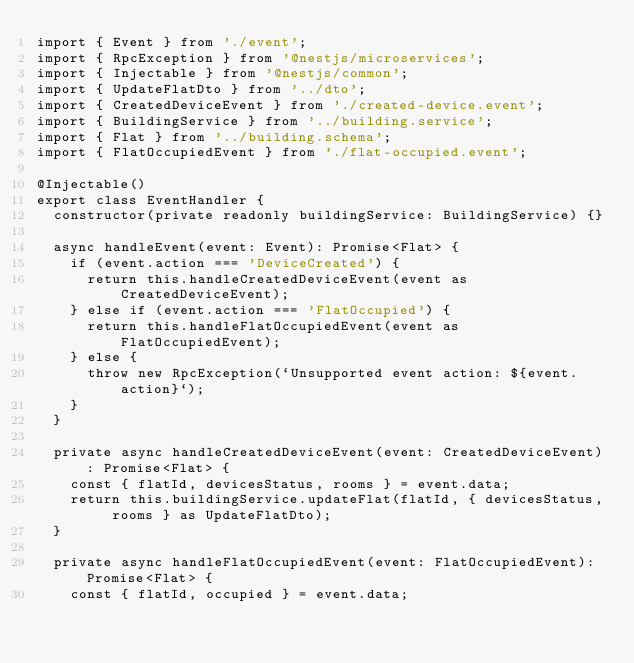Convert code to text. <code><loc_0><loc_0><loc_500><loc_500><_TypeScript_>import { Event } from './event';
import { RpcException } from '@nestjs/microservices';
import { Injectable } from '@nestjs/common';
import { UpdateFlatDto } from '../dto';
import { CreatedDeviceEvent } from './created-device.event';
import { BuildingService } from '../building.service';
import { Flat } from '../building.schema';
import { FlatOccupiedEvent } from './flat-occupied.event';

@Injectable()
export class EventHandler {
  constructor(private readonly buildingService: BuildingService) {}

  async handleEvent(event: Event): Promise<Flat> {
    if (event.action === 'DeviceCreated') {
      return this.handleCreatedDeviceEvent(event as CreatedDeviceEvent);
    } else if (event.action === 'FlatOccupied') {
      return this.handleFlatOccupiedEvent(event as FlatOccupiedEvent);
    } else {
      throw new RpcException(`Unsupported event action: ${event.action}`);
    }
  }

  private async handleCreatedDeviceEvent(event: CreatedDeviceEvent): Promise<Flat> {
    const { flatId, devicesStatus, rooms } = event.data;
    return this.buildingService.updateFlat(flatId, { devicesStatus, rooms } as UpdateFlatDto);
  }

  private async handleFlatOccupiedEvent(event: FlatOccupiedEvent): Promise<Flat> {
    const { flatId, occupied } = event.data;</code> 